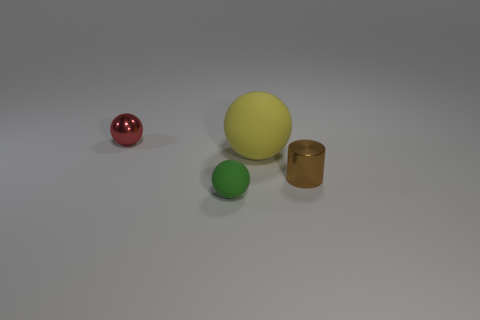Are there any other things that have the same size as the yellow ball?
Ensure brevity in your answer.  No. There is a metallic thing on the left side of the small object in front of the tiny brown object; what number of red balls are behind it?
Your answer should be compact. 0. The other rubber object that is the same shape as the green matte object is what color?
Your answer should be very brief. Yellow. Is there any other thing that is the same shape as the tiny brown thing?
Your response must be concise. No. How many balls are small red shiny things or green rubber objects?
Give a very brief answer. 2. What is the shape of the red object?
Your response must be concise. Sphere. There is a yellow sphere; are there any things to the right of it?
Provide a short and direct response. Yes. Do the brown cylinder and the small sphere that is behind the brown metallic object have the same material?
Provide a succinct answer. Yes. There is a rubber thing in front of the yellow rubber sphere; is its shape the same as the small red thing?
Offer a terse response. Yes. What number of red objects have the same material as the tiny brown thing?
Ensure brevity in your answer.  1. 